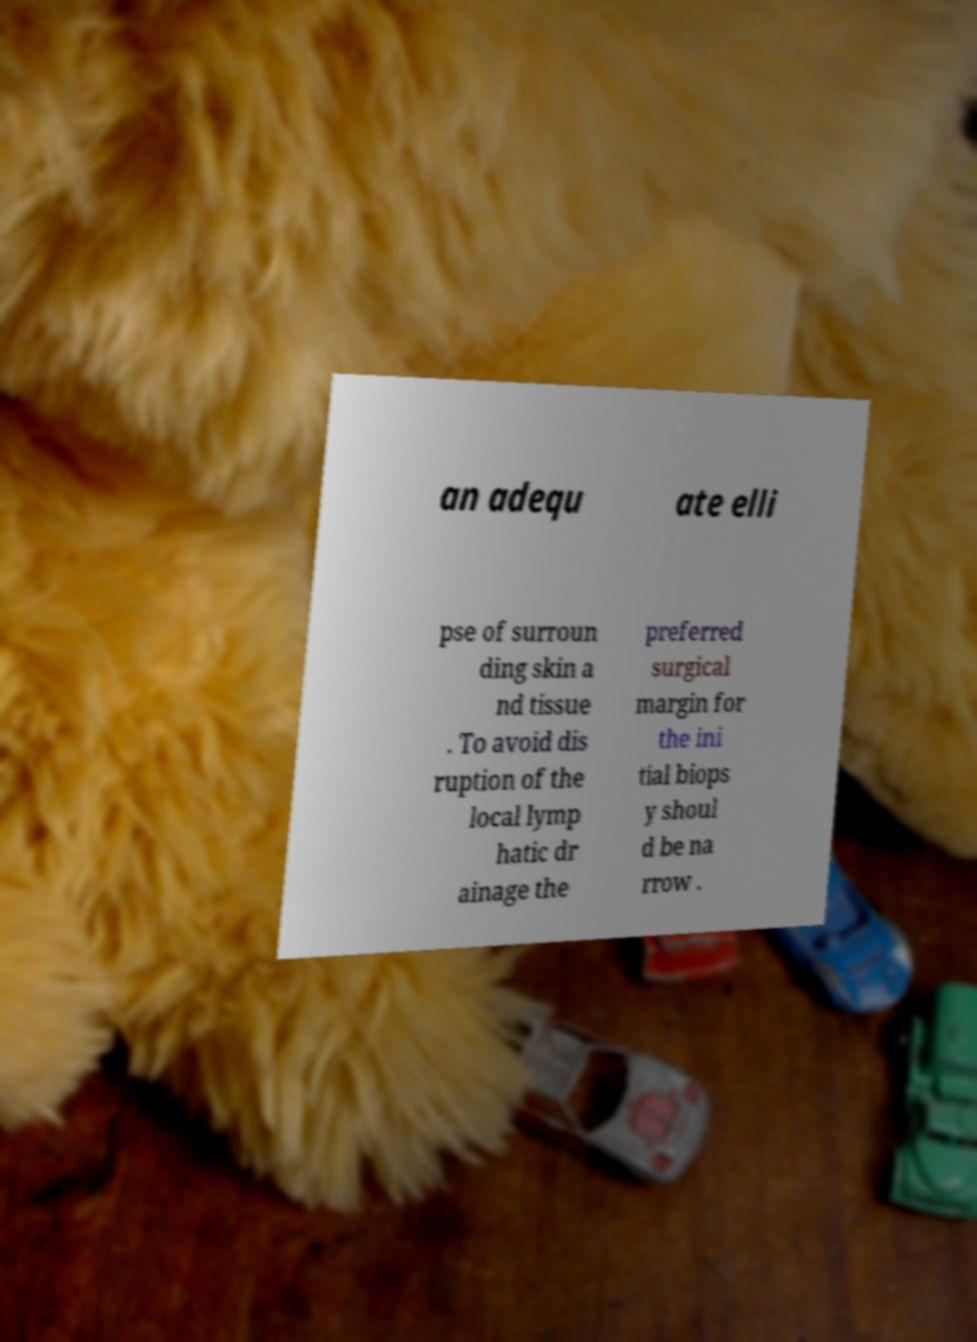For documentation purposes, I need the text within this image transcribed. Could you provide that? an adequ ate elli pse of surroun ding skin a nd tissue . To avoid dis ruption of the local lymp hatic dr ainage the preferred surgical margin for the ini tial biops y shoul d be na rrow . 